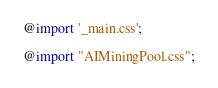Convert code to text. <code><loc_0><loc_0><loc_500><loc_500><_CSS_>@import '_main.css';

@import "AIMiningPool.css";


</code> 